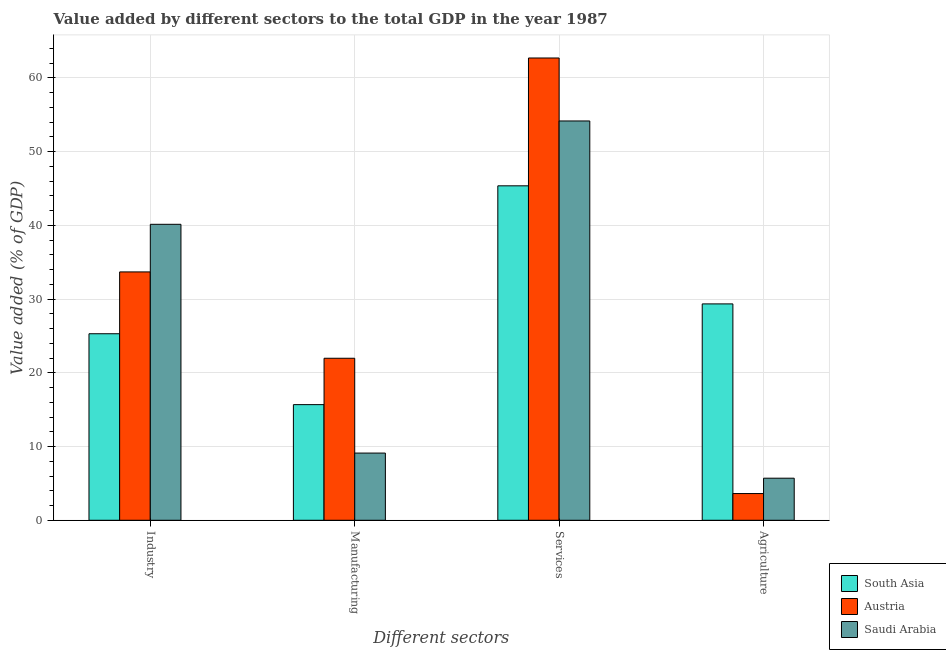Are the number of bars on each tick of the X-axis equal?
Your answer should be very brief. Yes. How many bars are there on the 3rd tick from the left?
Offer a terse response. 3. How many bars are there on the 4th tick from the right?
Provide a short and direct response. 3. What is the label of the 2nd group of bars from the left?
Provide a succinct answer. Manufacturing. What is the value added by agricultural sector in Saudi Arabia?
Your answer should be compact. 5.71. Across all countries, what is the maximum value added by services sector?
Your answer should be very brief. 62.69. Across all countries, what is the minimum value added by services sector?
Make the answer very short. 45.36. In which country was the value added by industrial sector maximum?
Give a very brief answer. Saudi Arabia. In which country was the value added by services sector minimum?
Your answer should be very brief. South Asia. What is the total value added by services sector in the graph?
Your answer should be very brief. 162.21. What is the difference between the value added by manufacturing sector in South Asia and that in Austria?
Offer a terse response. -6.29. What is the difference between the value added by agricultural sector in South Asia and the value added by services sector in Austria?
Provide a short and direct response. -33.35. What is the average value added by services sector per country?
Keep it short and to the point. 54.07. What is the difference between the value added by agricultural sector and value added by services sector in South Asia?
Provide a succinct answer. -16.02. What is the ratio of the value added by manufacturing sector in South Asia to that in Austria?
Ensure brevity in your answer.  0.71. Is the difference between the value added by services sector in Austria and Saudi Arabia greater than the difference between the value added by agricultural sector in Austria and Saudi Arabia?
Give a very brief answer. Yes. What is the difference between the highest and the second highest value added by agricultural sector?
Your answer should be very brief. 23.64. What is the difference between the highest and the lowest value added by services sector?
Offer a terse response. 17.34. Is the sum of the value added by manufacturing sector in Saudi Arabia and South Asia greater than the maximum value added by services sector across all countries?
Your answer should be very brief. No. What does the 2nd bar from the right in Agriculture represents?
Your answer should be very brief. Austria. Is it the case that in every country, the sum of the value added by industrial sector and value added by manufacturing sector is greater than the value added by services sector?
Your answer should be very brief. No. How many countries are there in the graph?
Your answer should be compact. 3. How are the legend labels stacked?
Ensure brevity in your answer.  Vertical. What is the title of the graph?
Offer a terse response. Value added by different sectors to the total GDP in the year 1987. What is the label or title of the X-axis?
Offer a terse response. Different sectors. What is the label or title of the Y-axis?
Offer a very short reply. Value added (% of GDP). What is the Value added (% of GDP) in South Asia in Industry?
Provide a short and direct response. 25.3. What is the Value added (% of GDP) of Austria in Industry?
Your answer should be compact. 33.68. What is the Value added (% of GDP) of Saudi Arabia in Industry?
Give a very brief answer. 40.14. What is the Value added (% of GDP) in South Asia in Manufacturing?
Your response must be concise. 15.68. What is the Value added (% of GDP) in Austria in Manufacturing?
Make the answer very short. 21.97. What is the Value added (% of GDP) of Saudi Arabia in Manufacturing?
Your answer should be compact. 9.11. What is the Value added (% of GDP) of South Asia in Services?
Make the answer very short. 45.36. What is the Value added (% of GDP) of Austria in Services?
Provide a short and direct response. 62.69. What is the Value added (% of GDP) of Saudi Arabia in Services?
Provide a succinct answer. 54.15. What is the Value added (% of GDP) in South Asia in Agriculture?
Your response must be concise. 29.34. What is the Value added (% of GDP) in Austria in Agriculture?
Your response must be concise. 3.62. What is the Value added (% of GDP) in Saudi Arabia in Agriculture?
Offer a very short reply. 5.71. Across all Different sectors, what is the maximum Value added (% of GDP) in South Asia?
Keep it short and to the point. 45.36. Across all Different sectors, what is the maximum Value added (% of GDP) in Austria?
Offer a very short reply. 62.69. Across all Different sectors, what is the maximum Value added (% of GDP) of Saudi Arabia?
Give a very brief answer. 54.15. Across all Different sectors, what is the minimum Value added (% of GDP) in South Asia?
Your answer should be very brief. 15.68. Across all Different sectors, what is the minimum Value added (% of GDP) of Austria?
Your answer should be compact. 3.62. Across all Different sectors, what is the minimum Value added (% of GDP) in Saudi Arabia?
Your answer should be compact. 5.71. What is the total Value added (% of GDP) of South Asia in the graph?
Offer a terse response. 115.68. What is the total Value added (% of GDP) of Austria in the graph?
Offer a terse response. 121.97. What is the total Value added (% of GDP) of Saudi Arabia in the graph?
Give a very brief answer. 109.11. What is the difference between the Value added (% of GDP) in South Asia in Industry and that in Manufacturing?
Your answer should be compact. 9.62. What is the difference between the Value added (% of GDP) of Austria in Industry and that in Manufacturing?
Ensure brevity in your answer.  11.71. What is the difference between the Value added (% of GDP) in Saudi Arabia in Industry and that in Manufacturing?
Your answer should be compact. 31.03. What is the difference between the Value added (% of GDP) in South Asia in Industry and that in Services?
Offer a terse response. -20.06. What is the difference between the Value added (% of GDP) of Austria in Industry and that in Services?
Your response must be concise. -29.01. What is the difference between the Value added (% of GDP) in Saudi Arabia in Industry and that in Services?
Offer a very short reply. -14.01. What is the difference between the Value added (% of GDP) of South Asia in Industry and that in Agriculture?
Provide a short and direct response. -4.05. What is the difference between the Value added (% of GDP) in Austria in Industry and that in Agriculture?
Keep it short and to the point. 30.06. What is the difference between the Value added (% of GDP) of Saudi Arabia in Industry and that in Agriculture?
Your response must be concise. 34.43. What is the difference between the Value added (% of GDP) in South Asia in Manufacturing and that in Services?
Provide a succinct answer. -29.68. What is the difference between the Value added (% of GDP) in Austria in Manufacturing and that in Services?
Ensure brevity in your answer.  -40.72. What is the difference between the Value added (% of GDP) in Saudi Arabia in Manufacturing and that in Services?
Ensure brevity in your answer.  -45.04. What is the difference between the Value added (% of GDP) of South Asia in Manufacturing and that in Agriculture?
Give a very brief answer. -13.66. What is the difference between the Value added (% of GDP) in Austria in Manufacturing and that in Agriculture?
Your answer should be compact. 18.35. What is the difference between the Value added (% of GDP) in Saudi Arabia in Manufacturing and that in Agriculture?
Offer a terse response. 3.41. What is the difference between the Value added (% of GDP) in South Asia in Services and that in Agriculture?
Provide a short and direct response. 16.02. What is the difference between the Value added (% of GDP) in Austria in Services and that in Agriculture?
Make the answer very short. 59.07. What is the difference between the Value added (% of GDP) in Saudi Arabia in Services and that in Agriculture?
Offer a very short reply. 48.45. What is the difference between the Value added (% of GDP) in South Asia in Industry and the Value added (% of GDP) in Austria in Manufacturing?
Provide a succinct answer. 3.33. What is the difference between the Value added (% of GDP) in South Asia in Industry and the Value added (% of GDP) in Saudi Arabia in Manufacturing?
Your answer should be very brief. 16.18. What is the difference between the Value added (% of GDP) in Austria in Industry and the Value added (% of GDP) in Saudi Arabia in Manufacturing?
Provide a succinct answer. 24.57. What is the difference between the Value added (% of GDP) of South Asia in Industry and the Value added (% of GDP) of Austria in Services?
Offer a terse response. -37.4. What is the difference between the Value added (% of GDP) in South Asia in Industry and the Value added (% of GDP) in Saudi Arabia in Services?
Keep it short and to the point. -28.86. What is the difference between the Value added (% of GDP) of Austria in Industry and the Value added (% of GDP) of Saudi Arabia in Services?
Ensure brevity in your answer.  -20.47. What is the difference between the Value added (% of GDP) of South Asia in Industry and the Value added (% of GDP) of Austria in Agriculture?
Keep it short and to the point. 21.67. What is the difference between the Value added (% of GDP) in South Asia in Industry and the Value added (% of GDP) in Saudi Arabia in Agriculture?
Your response must be concise. 19.59. What is the difference between the Value added (% of GDP) in Austria in Industry and the Value added (% of GDP) in Saudi Arabia in Agriculture?
Keep it short and to the point. 27.98. What is the difference between the Value added (% of GDP) in South Asia in Manufacturing and the Value added (% of GDP) in Austria in Services?
Your answer should be compact. -47.01. What is the difference between the Value added (% of GDP) in South Asia in Manufacturing and the Value added (% of GDP) in Saudi Arabia in Services?
Your answer should be very brief. -38.47. What is the difference between the Value added (% of GDP) in Austria in Manufacturing and the Value added (% of GDP) in Saudi Arabia in Services?
Your answer should be very brief. -32.18. What is the difference between the Value added (% of GDP) in South Asia in Manufacturing and the Value added (% of GDP) in Austria in Agriculture?
Ensure brevity in your answer.  12.06. What is the difference between the Value added (% of GDP) in South Asia in Manufacturing and the Value added (% of GDP) in Saudi Arabia in Agriculture?
Your answer should be compact. 9.98. What is the difference between the Value added (% of GDP) of Austria in Manufacturing and the Value added (% of GDP) of Saudi Arabia in Agriculture?
Keep it short and to the point. 16.27. What is the difference between the Value added (% of GDP) of South Asia in Services and the Value added (% of GDP) of Austria in Agriculture?
Give a very brief answer. 41.74. What is the difference between the Value added (% of GDP) of South Asia in Services and the Value added (% of GDP) of Saudi Arabia in Agriculture?
Your answer should be very brief. 39.65. What is the difference between the Value added (% of GDP) of Austria in Services and the Value added (% of GDP) of Saudi Arabia in Agriculture?
Provide a succinct answer. 56.99. What is the average Value added (% of GDP) in South Asia per Different sectors?
Offer a terse response. 28.92. What is the average Value added (% of GDP) in Austria per Different sectors?
Make the answer very short. 30.49. What is the average Value added (% of GDP) of Saudi Arabia per Different sectors?
Make the answer very short. 27.28. What is the difference between the Value added (% of GDP) of South Asia and Value added (% of GDP) of Austria in Industry?
Your answer should be compact. -8.38. What is the difference between the Value added (% of GDP) of South Asia and Value added (% of GDP) of Saudi Arabia in Industry?
Provide a succinct answer. -14.84. What is the difference between the Value added (% of GDP) of Austria and Value added (% of GDP) of Saudi Arabia in Industry?
Give a very brief answer. -6.46. What is the difference between the Value added (% of GDP) of South Asia and Value added (% of GDP) of Austria in Manufacturing?
Keep it short and to the point. -6.29. What is the difference between the Value added (% of GDP) of South Asia and Value added (% of GDP) of Saudi Arabia in Manufacturing?
Your answer should be very brief. 6.57. What is the difference between the Value added (% of GDP) of Austria and Value added (% of GDP) of Saudi Arabia in Manufacturing?
Provide a succinct answer. 12.86. What is the difference between the Value added (% of GDP) of South Asia and Value added (% of GDP) of Austria in Services?
Make the answer very short. -17.34. What is the difference between the Value added (% of GDP) of South Asia and Value added (% of GDP) of Saudi Arabia in Services?
Offer a very short reply. -8.8. What is the difference between the Value added (% of GDP) of Austria and Value added (% of GDP) of Saudi Arabia in Services?
Give a very brief answer. 8.54. What is the difference between the Value added (% of GDP) of South Asia and Value added (% of GDP) of Austria in Agriculture?
Offer a terse response. 25.72. What is the difference between the Value added (% of GDP) of South Asia and Value added (% of GDP) of Saudi Arabia in Agriculture?
Your answer should be very brief. 23.64. What is the difference between the Value added (% of GDP) in Austria and Value added (% of GDP) in Saudi Arabia in Agriculture?
Your response must be concise. -2.08. What is the ratio of the Value added (% of GDP) of South Asia in Industry to that in Manufacturing?
Offer a very short reply. 1.61. What is the ratio of the Value added (% of GDP) in Austria in Industry to that in Manufacturing?
Your answer should be very brief. 1.53. What is the ratio of the Value added (% of GDP) of Saudi Arabia in Industry to that in Manufacturing?
Your answer should be compact. 4.4. What is the ratio of the Value added (% of GDP) in South Asia in Industry to that in Services?
Your answer should be compact. 0.56. What is the ratio of the Value added (% of GDP) of Austria in Industry to that in Services?
Your response must be concise. 0.54. What is the ratio of the Value added (% of GDP) in Saudi Arabia in Industry to that in Services?
Ensure brevity in your answer.  0.74. What is the ratio of the Value added (% of GDP) of South Asia in Industry to that in Agriculture?
Provide a short and direct response. 0.86. What is the ratio of the Value added (% of GDP) in Austria in Industry to that in Agriculture?
Keep it short and to the point. 9.3. What is the ratio of the Value added (% of GDP) of Saudi Arabia in Industry to that in Agriculture?
Give a very brief answer. 7.03. What is the ratio of the Value added (% of GDP) in South Asia in Manufacturing to that in Services?
Provide a short and direct response. 0.35. What is the ratio of the Value added (% of GDP) of Austria in Manufacturing to that in Services?
Give a very brief answer. 0.35. What is the ratio of the Value added (% of GDP) in Saudi Arabia in Manufacturing to that in Services?
Provide a succinct answer. 0.17. What is the ratio of the Value added (% of GDP) of South Asia in Manufacturing to that in Agriculture?
Provide a succinct answer. 0.53. What is the ratio of the Value added (% of GDP) of Austria in Manufacturing to that in Agriculture?
Your answer should be compact. 6.06. What is the ratio of the Value added (% of GDP) of Saudi Arabia in Manufacturing to that in Agriculture?
Provide a succinct answer. 1.6. What is the ratio of the Value added (% of GDP) of South Asia in Services to that in Agriculture?
Provide a short and direct response. 1.55. What is the ratio of the Value added (% of GDP) of Austria in Services to that in Agriculture?
Offer a very short reply. 17.3. What is the ratio of the Value added (% of GDP) in Saudi Arabia in Services to that in Agriculture?
Your response must be concise. 9.49. What is the difference between the highest and the second highest Value added (% of GDP) of South Asia?
Your answer should be very brief. 16.02. What is the difference between the highest and the second highest Value added (% of GDP) of Austria?
Your answer should be very brief. 29.01. What is the difference between the highest and the second highest Value added (% of GDP) of Saudi Arabia?
Your answer should be compact. 14.01. What is the difference between the highest and the lowest Value added (% of GDP) in South Asia?
Offer a terse response. 29.68. What is the difference between the highest and the lowest Value added (% of GDP) in Austria?
Ensure brevity in your answer.  59.07. What is the difference between the highest and the lowest Value added (% of GDP) in Saudi Arabia?
Make the answer very short. 48.45. 